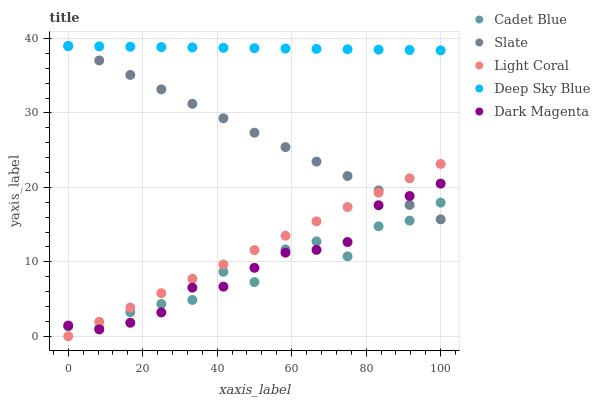Does Cadet Blue have the minimum area under the curve?
Answer yes or no. Yes. Does Deep Sky Blue have the maximum area under the curve?
Answer yes or no. Yes. Does Slate have the minimum area under the curve?
Answer yes or no. No. Does Slate have the maximum area under the curve?
Answer yes or no. No. Is Deep Sky Blue the smoothest?
Answer yes or no. Yes. Is Cadet Blue the roughest?
Answer yes or no. Yes. Is Slate the smoothest?
Answer yes or no. No. Is Slate the roughest?
Answer yes or no. No. Does Light Coral have the lowest value?
Answer yes or no. Yes. Does Slate have the lowest value?
Answer yes or no. No. Does Deep Sky Blue have the highest value?
Answer yes or no. Yes. Does Cadet Blue have the highest value?
Answer yes or no. No. Is Light Coral less than Deep Sky Blue?
Answer yes or no. Yes. Is Deep Sky Blue greater than Dark Magenta?
Answer yes or no. Yes. Does Slate intersect Deep Sky Blue?
Answer yes or no. Yes. Is Slate less than Deep Sky Blue?
Answer yes or no. No. Is Slate greater than Deep Sky Blue?
Answer yes or no. No. Does Light Coral intersect Deep Sky Blue?
Answer yes or no. No. 